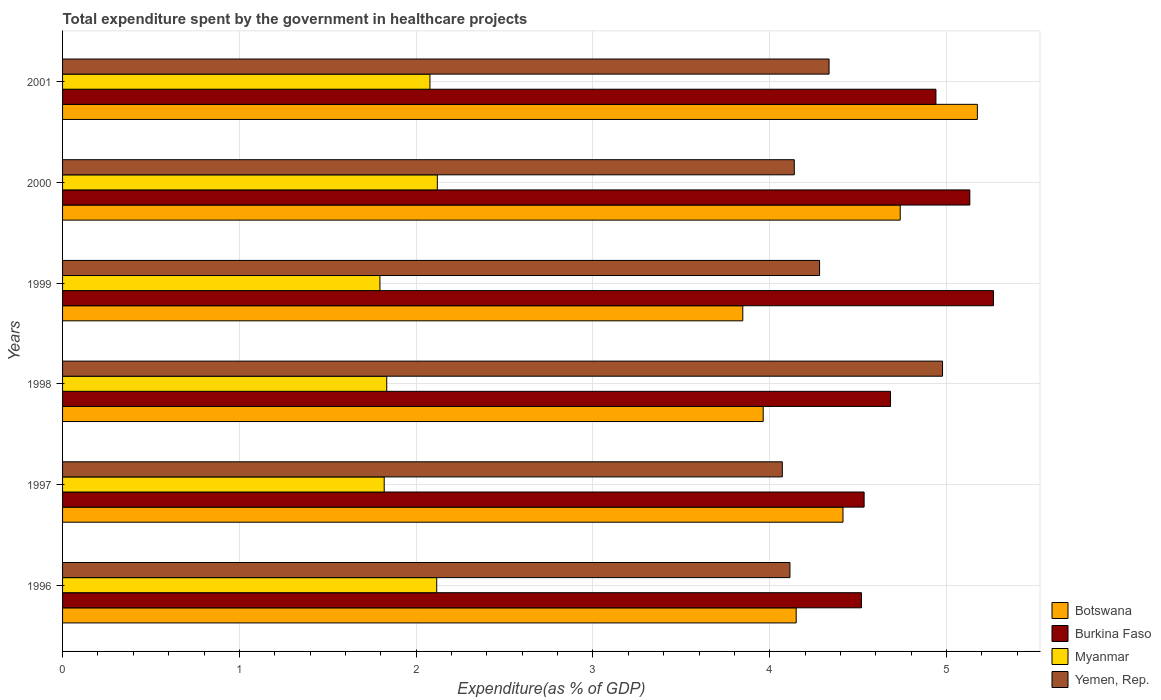How many groups of bars are there?
Offer a terse response. 6. Are the number of bars per tick equal to the number of legend labels?
Make the answer very short. Yes. Are the number of bars on each tick of the Y-axis equal?
Your answer should be very brief. Yes. How many bars are there on the 5th tick from the top?
Ensure brevity in your answer.  4. How many bars are there on the 4th tick from the bottom?
Ensure brevity in your answer.  4. What is the total expenditure spent by the government in healthcare projects in Botswana in 1997?
Provide a short and direct response. 4.41. Across all years, what is the maximum total expenditure spent by the government in healthcare projects in Burkina Faso?
Your response must be concise. 5.26. Across all years, what is the minimum total expenditure spent by the government in healthcare projects in Myanmar?
Your response must be concise. 1.8. In which year was the total expenditure spent by the government in healthcare projects in Botswana maximum?
Offer a terse response. 2001. What is the total total expenditure spent by the government in healthcare projects in Botswana in the graph?
Make the answer very short. 26.29. What is the difference between the total expenditure spent by the government in healthcare projects in Yemen, Rep. in 1999 and that in 2001?
Provide a short and direct response. -0.05. What is the difference between the total expenditure spent by the government in healthcare projects in Botswana in 2000 and the total expenditure spent by the government in healthcare projects in Yemen, Rep. in 2001?
Your answer should be compact. 0.4. What is the average total expenditure spent by the government in healthcare projects in Burkina Faso per year?
Give a very brief answer. 4.85. In the year 1997, what is the difference between the total expenditure spent by the government in healthcare projects in Yemen, Rep. and total expenditure spent by the government in healthcare projects in Burkina Faso?
Offer a very short reply. -0.46. What is the ratio of the total expenditure spent by the government in healthcare projects in Burkina Faso in 1997 to that in 1999?
Make the answer very short. 0.86. Is the difference between the total expenditure spent by the government in healthcare projects in Yemen, Rep. in 1997 and 1998 greater than the difference between the total expenditure spent by the government in healthcare projects in Burkina Faso in 1997 and 1998?
Your answer should be very brief. No. What is the difference between the highest and the second highest total expenditure spent by the government in healthcare projects in Botswana?
Keep it short and to the point. 0.44. What is the difference between the highest and the lowest total expenditure spent by the government in healthcare projects in Yemen, Rep.?
Keep it short and to the point. 0.91. In how many years, is the total expenditure spent by the government in healthcare projects in Myanmar greater than the average total expenditure spent by the government in healthcare projects in Myanmar taken over all years?
Your response must be concise. 3. Is the sum of the total expenditure spent by the government in healthcare projects in Yemen, Rep. in 1997 and 1999 greater than the maximum total expenditure spent by the government in healthcare projects in Burkina Faso across all years?
Ensure brevity in your answer.  Yes. Is it the case that in every year, the sum of the total expenditure spent by the government in healthcare projects in Botswana and total expenditure spent by the government in healthcare projects in Yemen, Rep. is greater than the sum of total expenditure spent by the government in healthcare projects in Burkina Faso and total expenditure spent by the government in healthcare projects in Myanmar?
Offer a very short reply. No. What does the 3rd bar from the top in 1997 represents?
Offer a very short reply. Burkina Faso. What does the 2nd bar from the bottom in 2000 represents?
Provide a succinct answer. Burkina Faso. Is it the case that in every year, the sum of the total expenditure spent by the government in healthcare projects in Yemen, Rep. and total expenditure spent by the government in healthcare projects in Myanmar is greater than the total expenditure spent by the government in healthcare projects in Botswana?
Your answer should be very brief. Yes. How many bars are there?
Your answer should be very brief. 24. Are all the bars in the graph horizontal?
Provide a succinct answer. Yes. What is the difference between two consecutive major ticks on the X-axis?
Provide a short and direct response. 1. Does the graph contain any zero values?
Keep it short and to the point. No. Where does the legend appear in the graph?
Provide a short and direct response. Bottom right. How many legend labels are there?
Provide a succinct answer. 4. What is the title of the graph?
Keep it short and to the point. Total expenditure spent by the government in healthcare projects. Does "Guinea" appear as one of the legend labels in the graph?
Keep it short and to the point. No. What is the label or title of the X-axis?
Your answer should be compact. Expenditure(as % of GDP). What is the Expenditure(as % of GDP) of Botswana in 1996?
Offer a very short reply. 4.15. What is the Expenditure(as % of GDP) of Burkina Faso in 1996?
Keep it short and to the point. 4.52. What is the Expenditure(as % of GDP) in Myanmar in 1996?
Give a very brief answer. 2.12. What is the Expenditure(as % of GDP) of Yemen, Rep. in 1996?
Offer a very short reply. 4.11. What is the Expenditure(as % of GDP) of Botswana in 1997?
Provide a succinct answer. 4.41. What is the Expenditure(as % of GDP) in Burkina Faso in 1997?
Your answer should be compact. 4.53. What is the Expenditure(as % of GDP) of Myanmar in 1997?
Make the answer very short. 1.82. What is the Expenditure(as % of GDP) of Yemen, Rep. in 1997?
Your response must be concise. 4.07. What is the Expenditure(as % of GDP) of Botswana in 1998?
Offer a terse response. 3.96. What is the Expenditure(as % of GDP) of Burkina Faso in 1998?
Ensure brevity in your answer.  4.68. What is the Expenditure(as % of GDP) in Myanmar in 1998?
Provide a succinct answer. 1.83. What is the Expenditure(as % of GDP) in Yemen, Rep. in 1998?
Give a very brief answer. 4.98. What is the Expenditure(as % of GDP) of Botswana in 1999?
Keep it short and to the point. 3.85. What is the Expenditure(as % of GDP) of Burkina Faso in 1999?
Provide a succinct answer. 5.26. What is the Expenditure(as % of GDP) in Myanmar in 1999?
Give a very brief answer. 1.8. What is the Expenditure(as % of GDP) in Yemen, Rep. in 1999?
Your response must be concise. 4.28. What is the Expenditure(as % of GDP) of Botswana in 2000?
Give a very brief answer. 4.74. What is the Expenditure(as % of GDP) of Burkina Faso in 2000?
Give a very brief answer. 5.13. What is the Expenditure(as % of GDP) of Myanmar in 2000?
Keep it short and to the point. 2.12. What is the Expenditure(as % of GDP) in Yemen, Rep. in 2000?
Provide a short and direct response. 4.14. What is the Expenditure(as % of GDP) in Botswana in 2001?
Keep it short and to the point. 5.17. What is the Expenditure(as % of GDP) of Burkina Faso in 2001?
Your answer should be very brief. 4.94. What is the Expenditure(as % of GDP) of Myanmar in 2001?
Your answer should be very brief. 2.08. What is the Expenditure(as % of GDP) in Yemen, Rep. in 2001?
Your answer should be very brief. 4.34. Across all years, what is the maximum Expenditure(as % of GDP) in Botswana?
Your answer should be very brief. 5.17. Across all years, what is the maximum Expenditure(as % of GDP) in Burkina Faso?
Offer a terse response. 5.26. Across all years, what is the maximum Expenditure(as % of GDP) of Myanmar?
Your answer should be compact. 2.12. Across all years, what is the maximum Expenditure(as % of GDP) of Yemen, Rep.?
Your response must be concise. 4.98. Across all years, what is the minimum Expenditure(as % of GDP) of Botswana?
Make the answer very short. 3.85. Across all years, what is the minimum Expenditure(as % of GDP) of Burkina Faso?
Offer a very short reply. 4.52. Across all years, what is the minimum Expenditure(as % of GDP) of Myanmar?
Ensure brevity in your answer.  1.8. Across all years, what is the minimum Expenditure(as % of GDP) in Yemen, Rep.?
Keep it short and to the point. 4.07. What is the total Expenditure(as % of GDP) in Botswana in the graph?
Ensure brevity in your answer.  26.29. What is the total Expenditure(as % of GDP) in Burkina Faso in the graph?
Offer a very short reply. 29.07. What is the total Expenditure(as % of GDP) in Myanmar in the graph?
Your answer should be very brief. 11.76. What is the total Expenditure(as % of GDP) of Yemen, Rep. in the graph?
Your response must be concise. 25.92. What is the difference between the Expenditure(as % of GDP) of Botswana in 1996 and that in 1997?
Offer a terse response. -0.26. What is the difference between the Expenditure(as % of GDP) in Burkina Faso in 1996 and that in 1997?
Keep it short and to the point. -0.01. What is the difference between the Expenditure(as % of GDP) in Myanmar in 1996 and that in 1997?
Provide a succinct answer. 0.3. What is the difference between the Expenditure(as % of GDP) in Yemen, Rep. in 1996 and that in 1997?
Ensure brevity in your answer.  0.04. What is the difference between the Expenditure(as % of GDP) of Botswana in 1996 and that in 1998?
Keep it short and to the point. 0.19. What is the difference between the Expenditure(as % of GDP) in Burkina Faso in 1996 and that in 1998?
Offer a terse response. -0.16. What is the difference between the Expenditure(as % of GDP) in Myanmar in 1996 and that in 1998?
Keep it short and to the point. 0.28. What is the difference between the Expenditure(as % of GDP) of Yemen, Rep. in 1996 and that in 1998?
Your answer should be compact. -0.86. What is the difference between the Expenditure(as % of GDP) of Botswana in 1996 and that in 1999?
Offer a very short reply. 0.3. What is the difference between the Expenditure(as % of GDP) in Burkina Faso in 1996 and that in 1999?
Provide a short and direct response. -0.75. What is the difference between the Expenditure(as % of GDP) in Myanmar in 1996 and that in 1999?
Provide a short and direct response. 0.32. What is the difference between the Expenditure(as % of GDP) in Yemen, Rep. in 1996 and that in 1999?
Give a very brief answer. -0.17. What is the difference between the Expenditure(as % of GDP) of Botswana in 1996 and that in 2000?
Your answer should be compact. -0.59. What is the difference between the Expenditure(as % of GDP) of Burkina Faso in 1996 and that in 2000?
Keep it short and to the point. -0.61. What is the difference between the Expenditure(as % of GDP) in Myanmar in 1996 and that in 2000?
Offer a very short reply. -0. What is the difference between the Expenditure(as % of GDP) in Yemen, Rep. in 1996 and that in 2000?
Keep it short and to the point. -0.02. What is the difference between the Expenditure(as % of GDP) of Botswana in 1996 and that in 2001?
Provide a succinct answer. -1.02. What is the difference between the Expenditure(as % of GDP) of Burkina Faso in 1996 and that in 2001?
Your response must be concise. -0.42. What is the difference between the Expenditure(as % of GDP) in Myanmar in 1996 and that in 2001?
Keep it short and to the point. 0.04. What is the difference between the Expenditure(as % of GDP) of Yemen, Rep. in 1996 and that in 2001?
Offer a very short reply. -0.22. What is the difference between the Expenditure(as % of GDP) of Botswana in 1997 and that in 1998?
Your response must be concise. 0.45. What is the difference between the Expenditure(as % of GDP) of Burkina Faso in 1997 and that in 1998?
Offer a terse response. -0.15. What is the difference between the Expenditure(as % of GDP) of Myanmar in 1997 and that in 1998?
Provide a short and direct response. -0.01. What is the difference between the Expenditure(as % of GDP) of Yemen, Rep. in 1997 and that in 1998?
Your response must be concise. -0.91. What is the difference between the Expenditure(as % of GDP) of Botswana in 1997 and that in 1999?
Your answer should be very brief. 0.57. What is the difference between the Expenditure(as % of GDP) in Burkina Faso in 1997 and that in 1999?
Ensure brevity in your answer.  -0.73. What is the difference between the Expenditure(as % of GDP) in Myanmar in 1997 and that in 1999?
Keep it short and to the point. 0.02. What is the difference between the Expenditure(as % of GDP) of Yemen, Rep. in 1997 and that in 1999?
Make the answer very short. -0.21. What is the difference between the Expenditure(as % of GDP) of Botswana in 1997 and that in 2000?
Your answer should be very brief. -0.32. What is the difference between the Expenditure(as % of GDP) in Burkina Faso in 1997 and that in 2000?
Make the answer very short. -0.6. What is the difference between the Expenditure(as % of GDP) in Myanmar in 1997 and that in 2000?
Your answer should be compact. -0.3. What is the difference between the Expenditure(as % of GDP) of Yemen, Rep. in 1997 and that in 2000?
Keep it short and to the point. -0.07. What is the difference between the Expenditure(as % of GDP) of Botswana in 1997 and that in 2001?
Your answer should be very brief. -0.76. What is the difference between the Expenditure(as % of GDP) of Burkina Faso in 1997 and that in 2001?
Provide a succinct answer. -0.41. What is the difference between the Expenditure(as % of GDP) in Myanmar in 1997 and that in 2001?
Offer a terse response. -0.26. What is the difference between the Expenditure(as % of GDP) in Yemen, Rep. in 1997 and that in 2001?
Keep it short and to the point. -0.26. What is the difference between the Expenditure(as % of GDP) of Botswana in 1998 and that in 1999?
Offer a terse response. 0.12. What is the difference between the Expenditure(as % of GDP) in Burkina Faso in 1998 and that in 1999?
Ensure brevity in your answer.  -0.58. What is the difference between the Expenditure(as % of GDP) of Myanmar in 1998 and that in 1999?
Provide a short and direct response. 0.04. What is the difference between the Expenditure(as % of GDP) in Yemen, Rep. in 1998 and that in 1999?
Make the answer very short. 0.7. What is the difference between the Expenditure(as % of GDP) in Botswana in 1998 and that in 2000?
Give a very brief answer. -0.77. What is the difference between the Expenditure(as % of GDP) of Burkina Faso in 1998 and that in 2000?
Make the answer very short. -0.45. What is the difference between the Expenditure(as % of GDP) of Myanmar in 1998 and that in 2000?
Your answer should be compact. -0.29. What is the difference between the Expenditure(as % of GDP) in Yemen, Rep. in 1998 and that in 2000?
Offer a terse response. 0.84. What is the difference between the Expenditure(as % of GDP) in Botswana in 1998 and that in 2001?
Provide a succinct answer. -1.21. What is the difference between the Expenditure(as % of GDP) of Burkina Faso in 1998 and that in 2001?
Your answer should be compact. -0.26. What is the difference between the Expenditure(as % of GDP) of Myanmar in 1998 and that in 2001?
Offer a terse response. -0.24. What is the difference between the Expenditure(as % of GDP) of Yemen, Rep. in 1998 and that in 2001?
Offer a terse response. 0.64. What is the difference between the Expenditure(as % of GDP) of Botswana in 1999 and that in 2000?
Give a very brief answer. -0.89. What is the difference between the Expenditure(as % of GDP) of Burkina Faso in 1999 and that in 2000?
Provide a succinct answer. 0.13. What is the difference between the Expenditure(as % of GDP) of Myanmar in 1999 and that in 2000?
Keep it short and to the point. -0.32. What is the difference between the Expenditure(as % of GDP) of Yemen, Rep. in 1999 and that in 2000?
Provide a succinct answer. 0.14. What is the difference between the Expenditure(as % of GDP) in Botswana in 1999 and that in 2001?
Keep it short and to the point. -1.33. What is the difference between the Expenditure(as % of GDP) of Burkina Faso in 1999 and that in 2001?
Make the answer very short. 0.33. What is the difference between the Expenditure(as % of GDP) in Myanmar in 1999 and that in 2001?
Give a very brief answer. -0.28. What is the difference between the Expenditure(as % of GDP) in Yemen, Rep. in 1999 and that in 2001?
Your response must be concise. -0.05. What is the difference between the Expenditure(as % of GDP) in Botswana in 2000 and that in 2001?
Keep it short and to the point. -0.44. What is the difference between the Expenditure(as % of GDP) in Burkina Faso in 2000 and that in 2001?
Your answer should be very brief. 0.19. What is the difference between the Expenditure(as % of GDP) of Myanmar in 2000 and that in 2001?
Give a very brief answer. 0.04. What is the difference between the Expenditure(as % of GDP) of Yemen, Rep. in 2000 and that in 2001?
Make the answer very short. -0.2. What is the difference between the Expenditure(as % of GDP) in Botswana in 1996 and the Expenditure(as % of GDP) in Burkina Faso in 1997?
Provide a succinct answer. -0.38. What is the difference between the Expenditure(as % of GDP) of Botswana in 1996 and the Expenditure(as % of GDP) of Myanmar in 1997?
Keep it short and to the point. 2.33. What is the difference between the Expenditure(as % of GDP) in Botswana in 1996 and the Expenditure(as % of GDP) in Yemen, Rep. in 1997?
Keep it short and to the point. 0.08. What is the difference between the Expenditure(as % of GDP) of Burkina Faso in 1996 and the Expenditure(as % of GDP) of Myanmar in 1997?
Give a very brief answer. 2.7. What is the difference between the Expenditure(as % of GDP) in Burkina Faso in 1996 and the Expenditure(as % of GDP) in Yemen, Rep. in 1997?
Offer a very short reply. 0.45. What is the difference between the Expenditure(as % of GDP) in Myanmar in 1996 and the Expenditure(as % of GDP) in Yemen, Rep. in 1997?
Your answer should be compact. -1.95. What is the difference between the Expenditure(as % of GDP) in Botswana in 1996 and the Expenditure(as % of GDP) in Burkina Faso in 1998?
Make the answer very short. -0.53. What is the difference between the Expenditure(as % of GDP) in Botswana in 1996 and the Expenditure(as % of GDP) in Myanmar in 1998?
Provide a short and direct response. 2.32. What is the difference between the Expenditure(as % of GDP) in Botswana in 1996 and the Expenditure(as % of GDP) in Yemen, Rep. in 1998?
Give a very brief answer. -0.83. What is the difference between the Expenditure(as % of GDP) in Burkina Faso in 1996 and the Expenditure(as % of GDP) in Myanmar in 1998?
Your answer should be compact. 2.69. What is the difference between the Expenditure(as % of GDP) in Burkina Faso in 1996 and the Expenditure(as % of GDP) in Yemen, Rep. in 1998?
Ensure brevity in your answer.  -0.46. What is the difference between the Expenditure(as % of GDP) of Myanmar in 1996 and the Expenditure(as % of GDP) of Yemen, Rep. in 1998?
Keep it short and to the point. -2.86. What is the difference between the Expenditure(as % of GDP) in Botswana in 1996 and the Expenditure(as % of GDP) in Burkina Faso in 1999?
Keep it short and to the point. -1.12. What is the difference between the Expenditure(as % of GDP) in Botswana in 1996 and the Expenditure(as % of GDP) in Myanmar in 1999?
Provide a succinct answer. 2.35. What is the difference between the Expenditure(as % of GDP) in Botswana in 1996 and the Expenditure(as % of GDP) in Yemen, Rep. in 1999?
Offer a very short reply. -0.13. What is the difference between the Expenditure(as % of GDP) in Burkina Faso in 1996 and the Expenditure(as % of GDP) in Myanmar in 1999?
Provide a succinct answer. 2.72. What is the difference between the Expenditure(as % of GDP) in Burkina Faso in 1996 and the Expenditure(as % of GDP) in Yemen, Rep. in 1999?
Your answer should be very brief. 0.24. What is the difference between the Expenditure(as % of GDP) in Myanmar in 1996 and the Expenditure(as % of GDP) in Yemen, Rep. in 1999?
Keep it short and to the point. -2.17. What is the difference between the Expenditure(as % of GDP) in Botswana in 1996 and the Expenditure(as % of GDP) in Burkina Faso in 2000?
Ensure brevity in your answer.  -0.98. What is the difference between the Expenditure(as % of GDP) in Botswana in 1996 and the Expenditure(as % of GDP) in Myanmar in 2000?
Give a very brief answer. 2.03. What is the difference between the Expenditure(as % of GDP) in Botswana in 1996 and the Expenditure(as % of GDP) in Yemen, Rep. in 2000?
Offer a very short reply. 0.01. What is the difference between the Expenditure(as % of GDP) of Burkina Faso in 1996 and the Expenditure(as % of GDP) of Myanmar in 2000?
Your response must be concise. 2.4. What is the difference between the Expenditure(as % of GDP) of Burkina Faso in 1996 and the Expenditure(as % of GDP) of Yemen, Rep. in 2000?
Your answer should be very brief. 0.38. What is the difference between the Expenditure(as % of GDP) in Myanmar in 1996 and the Expenditure(as % of GDP) in Yemen, Rep. in 2000?
Offer a terse response. -2.02. What is the difference between the Expenditure(as % of GDP) in Botswana in 1996 and the Expenditure(as % of GDP) in Burkina Faso in 2001?
Your answer should be very brief. -0.79. What is the difference between the Expenditure(as % of GDP) of Botswana in 1996 and the Expenditure(as % of GDP) of Myanmar in 2001?
Give a very brief answer. 2.07. What is the difference between the Expenditure(as % of GDP) in Botswana in 1996 and the Expenditure(as % of GDP) in Yemen, Rep. in 2001?
Provide a short and direct response. -0.19. What is the difference between the Expenditure(as % of GDP) in Burkina Faso in 1996 and the Expenditure(as % of GDP) in Myanmar in 2001?
Provide a succinct answer. 2.44. What is the difference between the Expenditure(as % of GDP) in Burkina Faso in 1996 and the Expenditure(as % of GDP) in Yemen, Rep. in 2001?
Ensure brevity in your answer.  0.18. What is the difference between the Expenditure(as % of GDP) of Myanmar in 1996 and the Expenditure(as % of GDP) of Yemen, Rep. in 2001?
Provide a short and direct response. -2.22. What is the difference between the Expenditure(as % of GDP) in Botswana in 1997 and the Expenditure(as % of GDP) in Burkina Faso in 1998?
Offer a terse response. -0.27. What is the difference between the Expenditure(as % of GDP) in Botswana in 1997 and the Expenditure(as % of GDP) in Myanmar in 1998?
Offer a terse response. 2.58. What is the difference between the Expenditure(as % of GDP) in Botswana in 1997 and the Expenditure(as % of GDP) in Yemen, Rep. in 1998?
Keep it short and to the point. -0.56. What is the difference between the Expenditure(as % of GDP) of Burkina Faso in 1997 and the Expenditure(as % of GDP) of Myanmar in 1998?
Provide a succinct answer. 2.7. What is the difference between the Expenditure(as % of GDP) of Burkina Faso in 1997 and the Expenditure(as % of GDP) of Yemen, Rep. in 1998?
Provide a short and direct response. -0.44. What is the difference between the Expenditure(as % of GDP) in Myanmar in 1997 and the Expenditure(as % of GDP) in Yemen, Rep. in 1998?
Your answer should be very brief. -3.16. What is the difference between the Expenditure(as % of GDP) in Botswana in 1997 and the Expenditure(as % of GDP) in Burkina Faso in 1999?
Ensure brevity in your answer.  -0.85. What is the difference between the Expenditure(as % of GDP) in Botswana in 1997 and the Expenditure(as % of GDP) in Myanmar in 1999?
Make the answer very short. 2.62. What is the difference between the Expenditure(as % of GDP) in Botswana in 1997 and the Expenditure(as % of GDP) in Yemen, Rep. in 1999?
Offer a terse response. 0.13. What is the difference between the Expenditure(as % of GDP) in Burkina Faso in 1997 and the Expenditure(as % of GDP) in Myanmar in 1999?
Offer a very short reply. 2.74. What is the difference between the Expenditure(as % of GDP) of Burkina Faso in 1997 and the Expenditure(as % of GDP) of Yemen, Rep. in 1999?
Provide a succinct answer. 0.25. What is the difference between the Expenditure(as % of GDP) in Myanmar in 1997 and the Expenditure(as % of GDP) in Yemen, Rep. in 1999?
Offer a terse response. -2.46. What is the difference between the Expenditure(as % of GDP) in Botswana in 1997 and the Expenditure(as % of GDP) in Burkina Faso in 2000?
Make the answer very short. -0.72. What is the difference between the Expenditure(as % of GDP) of Botswana in 1997 and the Expenditure(as % of GDP) of Myanmar in 2000?
Your response must be concise. 2.29. What is the difference between the Expenditure(as % of GDP) in Botswana in 1997 and the Expenditure(as % of GDP) in Yemen, Rep. in 2000?
Keep it short and to the point. 0.28. What is the difference between the Expenditure(as % of GDP) in Burkina Faso in 1997 and the Expenditure(as % of GDP) in Myanmar in 2000?
Provide a succinct answer. 2.41. What is the difference between the Expenditure(as % of GDP) of Burkina Faso in 1997 and the Expenditure(as % of GDP) of Yemen, Rep. in 2000?
Your answer should be compact. 0.4. What is the difference between the Expenditure(as % of GDP) in Myanmar in 1997 and the Expenditure(as % of GDP) in Yemen, Rep. in 2000?
Provide a succinct answer. -2.32. What is the difference between the Expenditure(as % of GDP) in Botswana in 1997 and the Expenditure(as % of GDP) in Burkina Faso in 2001?
Keep it short and to the point. -0.53. What is the difference between the Expenditure(as % of GDP) of Botswana in 1997 and the Expenditure(as % of GDP) of Myanmar in 2001?
Give a very brief answer. 2.34. What is the difference between the Expenditure(as % of GDP) in Botswana in 1997 and the Expenditure(as % of GDP) in Yemen, Rep. in 2001?
Give a very brief answer. 0.08. What is the difference between the Expenditure(as % of GDP) in Burkina Faso in 1997 and the Expenditure(as % of GDP) in Myanmar in 2001?
Offer a terse response. 2.46. What is the difference between the Expenditure(as % of GDP) in Burkina Faso in 1997 and the Expenditure(as % of GDP) in Yemen, Rep. in 2001?
Your answer should be compact. 0.2. What is the difference between the Expenditure(as % of GDP) in Myanmar in 1997 and the Expenditure(as % of GDP) in Yemen, Rep. in 2001?
Your answer should be compact. -2.52. What is the difference between the Expenditure(as % of GDP) in Botswana in 1998 and the Expenditure(as % of GDP) in Burkina Faso in 1999?
Your answer should be very brief. -1.3. What is the difference between the Expenditure(as % of GDP) in Botswana in 1998 and the Expenditure(as % of GDP) in Myanmar in 1999?
Provide a short and direct response. 2.17. What is the difference between the Expenditure(as % of GDP) of Botswana in 1998 and the Expenditure(as % of GDP) of Yemen, Rep. in 1999?
Offer a very short reply. -0.32. What is the difference between the Expenditure(as % of GDP) in Burkina Faso in 1998 and the Expenditure(as % of GDP) in Myanmar in 1999?
Offer a terse response. 2.89. What is the difference between the Expenditure(as % of GDP) in Burkina Faso in 1998 and the Expenditure(as % of GDP) in Yemen, Rep. in 1999?
Offer a very short reply. 0.4. What is the difference between the Expenditure(as % of GDP) of Myanmar in 1998 and the Expenditure(as % of GDP) of Yemen, Rep. in 1999?
Give a very brief answer. -2.45. What is the difference between the Expenditure(as % of GDP) in Botswana in 1998 and the Expenditure(as % of GDP) in Burkina Faso in 2000?
Provide a succinct answer. -1.17. What is the difference between the Expenditure(as % of GDP) of Botswana in 1998 and the Expenditure(as % of GDP) of Myanmar in 2000?
Make the answer very short. 1.84. What is the difference between the Expenditure(as % of GDP) of Botswana in 1998 and the Expenditure(as % of GDP) of Yemen, Rep. in 2000?
Make the answer very short. -0.18. What is the difference between the Expenditure(as % of GDP) in Burkina Faso in 1998 and the Expenditure(as % of GDP) in Myanmar in 2000?
Your response must be concise. 2.56. What is the difference between the Expenditure(as % of GDP) of Burkina Faso in 1998 and the Expenditure(as % of GDP) of Yemen, Rep. in 2000?
Provide a succinct answer. 0.54. What is the difference between the Expenditure(as % of GDP) of Myanmar in 1998 and the Expenditure(as % of GDP) of Yemen, Rep. in 2000?
Provide a short and direct response. -2.31. What is the difference between the Expenditure(as % of GDP) of Botswana in 1998 and the Expenditure(as % of GDP) of Burkina Faso in 2001?
Your response must be concise. -0.98. What is the difference between the Expenditure(as % of GDP) of Botswana in 1998 and the Expenditure(as % of GDP) of Myanmar in 2001?
Provide a short and direct response. 1.89. What is the difference between the Expenditure(as % of GDP) of Botswana in 1998 and the Expenditure(as % of GDP) of Yemen, Rep. in 2001?
Provide a short and direct response. -0.37. What is the difference between the Expenditure(as % of GDP) of Burkina Faso in 1998 and the Expenditure(as % of GDP) of Myanmar in 2001?
Keep it short and to the point. 2.6. What is the difference between the Expenditure(as % of GDP) of Burkina Faso in 1998 and the Expenditure(as % of GDP) of Yemen, Rep. in 2001?
Provide a short and direct response. 0.35. What is the difference between the Expenditure(as % of GDP) of Myanmar in 1998 and the Expenditure(as % of GDP) of Yemen, Rep. in 2001?
Provide a short and direct response. -2.5. What is the difference between the Expenditure(as % of GDP) of Botswana in 1999 and the Expenditure(as % of GDP) of Burkina Faso in 2000?
Make the answer very short. -1.28. What is the difference between the Expenditure(as % of GDP) of Botswana in 1999 and the Expenditure(as % of GDP) of Myanmar in 2000?
Give a very brief answer. 1.73. What is the difference between the Expenditure(as % of GDP) in Botswana in 1999 and the Expenditure(as % of GDP) in Yemen, Rep. in 2000?
Make the answer very short. -0.29. What is the difference between the Expenditure(as % of GDP) of Burkina Faso in 1999 and the Expenditure(as % of GDP) of Myanmar in 2000?
Provide a short and direct response. 3.15. What is the difference between the Expenditure(as % of GDP) in Burkina Faso in 1999 and the Expenditure(as % of GDP) in Yemen, Rep. in 2000?
Give a very brief answer. 1.13. What is the difference between the Expenditure(as % of GDP) in Myanmar in 1999 and the Expenditure(as % of GDP) in Yemen, Rep. in 2000?
Offer a very short reply. -2.34. What is the difference between the Expenditure(as % of GDP) of Botswana in 1999 and the Expenditure(as % of GDP) of Burkina Faso in 2001?
Your answer should be very brief. -1.09. What is the difference between the Expenditure(as % of GDP) in Botswana in 1999 and the Expenditure(as % of GDP) in Myanmar in 2001?
Provide a succinct answer. 1.77. What is the difference between the Expenditure(as % of GDP) in Botswana in 1999 and the Expenditure(as % of GDP) in Yemen, Rep. in 2001?
Make the answer very short. -0.49. What is the difference between the Expenditure(as % of GDP) of Burkina Faso in 1999 and the Expenditure(as % of GDP) of Myanmar in 2001?
Give a very brief answer. 3.19. What is the difference between the Expenditure(as % of GDP) in Burkina Faso in 1999 and the Expenditure(as % of GDP) in Yemen, Rep. in 2001?
Your response must be concise. 0.93. What is the difference between the Expenditure(as % of GDP) of Myanmar in 1999 and the Expenditure(as % of GDP) of Yemen, Rep. in 2001?
Your answer should be compact. -2.54. What is the difference between the Expenditure(as % of GDP) in Botswana in 2000 and the Expenditure(as % of GDP) in Burkina Faso in 2001?
Offer a very short reply. -0.2. What is the difference between the Expenditure(as % of GDP) of Botswana in 2000 and the Expenditure(as % of GDP) of Myanmar in 2001?
Your answer should be compact. 2.66. What is the difference between the Expenditure(as % of GDP) in Botswana in 2000 and the Expenditure(as % of GDP) in Yemen, Rep. in 2001?
Your answer should be very brief. 0.4. What is the difference between the Expenditure(as % of GDP) of Burkina Faso in 2000 and the Expenditure(as % of GDP) of Myanmar in 2001?
Your response must be concise. 3.05. What is the difference between the Expenditure(as % of GDP) of Burkina Faso in 2000 and the Expenditure(as % of GDP) of Yemen, Rep. in 2001?
Your answer should be very brief. 0.8. What is the difference between the Expenditure(as % of GDP) of Myanmar in 2000 and the Expenditure(as % of GDP) of Yemen, Rep. in 2001?
Provide a succinct answer. -2.22. What is the average Expenditure(as % of GDP) of Botswana per year?
Ensure brevity in your answer.  4.38. What is the average Expenditure(as % of GDP) in Burkina Faso per year?
Offer a terse response. 4.85. What is the average Expenditure(as % of GDP) of Myanmar per year?
Provide a short and direct response. 1.96. What is the average Expenditure(as % of GDP) in Yemen, Rep. per year?
Offer a very short reply. 4.32. In the year 1996, what is the difference between the Expenditure(as % of GDP) in Botswana and Expenditure(as % of GDP) in Burkina Faso?
Your response must be concise. -0.37. In the year 1996, what is the difference between the Expenditure(as % of GDP) in Botswana and Expenditure(as % of GDP) in Myanmar?
Provide a succinct answer. 2.03. In the year 1996, what is the difference between the Expenditure(as % of GDP) in Botswana and Expenditure(as % of GDP) in Yemen, Rep.?
Your response must be concise. 0.04. In the year 1996, what is the difference between the Expenditure(as % of GDP) in Burkina Faso and Expenditure(as % of GDP) in Myanmar?
Offer a very short reply. 2.4. In the year 1996, what is the difference between the Expenditure(as % of GDP) in Burkina Faso and Expenditure(as % of GDP) in Yemen, Rep.?
Provide a succinct answer. 0.4. In the year 1996, what is the difference between the Expenditure(as % of GDP) in Myanmar and Expenditure(as % of GDP) in Yemen, Rep.?
Your response must be concise. -2. In the year 1997, what is the difference between the Expenditure(as % of GDP) in Botswana and Expenditure(as % of GDP) in Burkina Faso?
Offer a very short reply. -0.12. In the year 1997, what is the difference between the Expenditure(as % of GDP) of Botswana and Expenditure(as % of GDP) of Myanmar?
Your answer should be compact. 2.6. In the year 1997, what is the difference between the Expenditure(as % of GDP) of Botswana and Expenditure(as % of GDP) of Yemen, Rep.?
Offer a terse response. 0.34. In the year 1997, what is the difference between the Expenditure(as % of GDP) of Burkina Faso and Expenditure(as % of GDP) of Myanmar?
Ensure brevity in your answer.  2.71. In the year 1997, what is the difference between the Expenditure(as % of GDP) in Burkina Faso and Expenditure(as % of GDP) in Yemen, Rep.?
Give a very brief answer. 0.46. In the year 1997, what is the difference between the Expenditure(as % of GDP) in Myanmar and Expenditure(as % of GDP) in Yemen, Rep.?
Provide a succinct answer. -2.25. In the year 1998, what is the difference between the Expenditure(as % of GDP) in Botswana and Expenditure(as % of GDP) in Burkina Faso?
Make the answer very short. -0.72. In the year 1998, what is the difference between the Expenditure(as % of GDP) in Botswana and Expenditure(as % of GDP) in Myanmar?
Offer a terse response. 2.13. In the year 1998, what is the difference between the Expenditure(as % of GDP) in Botswana and Expenditure(as % of GDP) in Yemen, Rep.?
Make the answer very short. -1.01. In the year 1998, what is the difference between the Expenditure(as % of GDP) of Burkina Faso and Expenditure(as % of GDP) of Myanmar?
Provide a succinct answer. 2.85. In the year 1998, what is the difference between the Expenditure(as % of GDP) of Burkina Faso and Expenditure(as % of GDP) of Yemen, Rep.?
Your response must be concise. -0.29. In the year 1998, what is the difference between the Expenditure(as % of GDP) of Myanmar and Expenditure(as % of GDP) of Yemen, Rep.?
Provide a succinct answer. -3.14. In the year 1999, what is the difference between the Expenditure(as % of GDP) in Botswana and Expenditure(as % of GDP) in Burkina Faso?
Your response must be concise. -1.42. In the year 1999, what is the difference between the Expenditure(as % of GDP) of Botswana and Expenditure(as % of GDP) of Myanmar?
Your answer should be compact. 2.05. In the year 1999, what is the difference between the Expenditure(as % of GDP) of Botswana and Expenditure(as % of GDP) of Yemen, Rep.?
Offer a very short reply. -0.43. In the year 1999, what is the difference between the Expenditure(as % of GDP) in Burkina Faso and Expenditure(as % of GDP) in Myanmar?
Offer a very short reply. 3.47. In the year 1999, what is the difference between the Expenditure(as % of GDP) in Burkina Faso and Expenditure(as % of GDP) in Yemen, Rep.?
Provide a succinct answer. 0.98. In the year 1999, what is the difference between the Expenditure(as % of GDP) in Myanmar and Expenditure(as % of GDP) in Yemen, Rep.?
Offer a terse response. -2.49. In the year 2000, what is the difference between the Expenditure(as % of GDP) of Botswana and Expenditure(as % of GDP) of Burkina Faso?
Offer a very short reply. -0.39. In the year 2000, what is the difference between the Expenditure(as % of GDP) in Botswana and Expenditure(as % of GDP) in Myanmar?
Your response must be concise. 2.62. In the year 2000, what is the difference between the Expenditure(as % of GDP) in Botswana and Expenditure(as % of GDP) in Yemen, Rep.?
Provide a succinct answer. 0.6. In the year 2000, what is the difference between the Expenditure(as % of GDP) of Burkina Faso and Expenditure(as % of GDP) of Myanmar?
Your answer should be very brief. 3.01. In the year 2000, what is the difference between the Expenditure(as % of GDP) of Myanmar and Expenditure(as % of GDP) of Yemen, Rep.?
Your response must be concise. -2.02. In the year 2001, what is the difference between the Expenditure(as % of GDP) in Botswana and Expenditure(as % of GDP) in Burkina Faso?
Ensure brevity in your answer.  0.23. In the year 2001, what is the difference between the Expenditure(as % of GDP) of Botswana and Expenditure(as % of GDP) of Myanmar?
Your response must be concise. 3.1. In the year 2001, what is the difference between the Expenditure(as % of GDP) in Botswana and Expenditure(as % of GDP) in Yemen, Rep.?
Make the answer very short. 0.84. In the year 2001, what is the difference between the Expenditure(as % of GDP) in Burkina Faso and Expenditure(as % of GDP) in Myanmar?
Your answer should be compact. 2.86. In the year 2001, what is the difference between the Expenditure(as % of GDP) in Burkina Faso and Expenditure(as % of GDP) in Yemen, Rep.?
Give a very brief answer. 0.6. In the year 2001, what is the difference between the Expenditure(as % of GDP) in Myanmar and Expenditure(as % of GDP) in Yemen, Rep.?
Provide a short and direct response. -2.26. What is the ratio of the Expenditure(as % of GDP) of Botswana in 1996 to that in 1997?
Your answer should be compact. 0.94. What is the ratio of the Expenditure(as % of GDP) in Burkina Faso in 1996 to that in 1997?
Make the answer very short. 1. What is the ratio of the Expenditure(as % of GDP) in Myanmar in 1996 to that in 1997?
Your answer should be compact. 1.16. What is the ratio of the Expenditure(as % of GDP) of Yemen, Rep. in 1996 to that in 1997?
Make the answer very short. 1.01. What is the ratio of the Expenditure(as % of GDP) in Botswana in 1996 to that in 1998?
Your response must be concise. 1.05. What is the ratio of the Expenditure(as % of GDP) of Burkina Faso in 1996 to that in 1998?
Your answer should be compact. 0.96. What is the ratio of the Expenditure(as % of GDP) of Myanmar in 1996 to that in 1998?
Give a very brief answer. 1.15. What is the ratio of the Expenditure(as % of GDP) in Yemen, Rep. in 1996 to that in 1998?
Offer a very short reply. 0.83. What is the ratio of the Expenditure(as % of GDP) of Botswana in 1996 to that in 1999?
Offer a terse response. 1.08. What is the ratio of the Expenditure(as % of GDP) in Burkina Faso in 1996 to that in 1999?
Offer a terse response. 0.86. What is the ratio of the Expenditure(as % of GDP) of Myanmar in 1996 to that in 1999?
Ensure brevity in your answer.  1.18. What is the ratio of the Expenditure(as % of GDP) in Yemen, Rep. in 1996 to that in 1999?
Offer a terse response. 0.96. What is the ratio of the Expenditure(as % of GDP) in Botswana in 1996 to that in 2000?
Give a very brief answer. 0.88. What is the ratio of the Expenditure(as % of GDP) in Burkina Faso in 1996 to that in 2000?
Provide a short and direct response. 0.88. What is the ratio of the Expenditure(as % of GDP) of Myanmar in 1996 to that in 2000?
Provide a short and direct response. 1. What is the ratio of the Expenditure(as % of GDP) in Yemen, Rep. in 1996 to that in 2000?
Ensure brevity in your answer.  0.99. What is the ratio of the Expenditure(as % of GDP) in Botswana in 1996 to that in 2001?
Provide a short and direct response. 0.8. What is the ratio of the Expenditure(as % of GDP) in Burkina Faso in 1996 to that in 2001?
Ensure brevity in your answer.  0.91. What is the ratio of the Expenditure(as % of GDP) of Myanmar in 1996 to that in 2001?
Provide a short and direct response. 1.02. What is the ratio of the Expenditure(as % of GDP) of Yemen, Rep. in 1996 to that in 2001?
Offer a terse response. 0.95. What is the ratio of the Expenditure(as % of GDP) in Botswana in 1997 to that in 1998?
Offer a very short reply. 1.11. What is the ratio of the Expenditure(as % of GDP) of Burkina Faso in 1997 to that in 1998?
Ensure brevity in your answer.  0.97. What is the ratio of the Expenditure(as % of GDP) in Myanmar in 1997 to that in 1998?
Give a very brief answer. 0.99. What is the ratio of the Expenditure(as % of GDP) in Yemen, Rep. in 1997 to that in 1998?
Offer a very short reply. 0.82. What is the ratio of the Expenditure(as % of GDP) in Botswana in 1997 to that in 1999?
Offer a very short reply. 1.15. What is the ratio of the Expenditure(as % of GDP) of Burkina Faso in 1997 to that in 1999?
Ensure brevity in your answer.  0.86. What is the ratio of the Expenditure(as % of GDP) of Myanmar in 1997 to that in 1999?
Offer a terse response. 1.01. What is the ratio of the Expenditure(as % of GDP) of Yemen, Rep. in 1997 to that in 1999?
Provide a succinct answer. 0.95. What is the ratio of the Expenditure(as % of GDP) of Botswana in 1997 to that in 2000?
Offer a terse response. 0.93. What is the ratio of the Expenditure(as % of GDP) of Burkina Faso in 1997 to that in 2000?
Keep it short and to the point. 0.88. What is the ratio of the Expenditure(as % of GDP) of Myanmar in 1997 to that in 2000?
Provide a succinct answer. 0.86. What is the ratio of the Expenditure(as % of GDP) in Yemen, Rep. in 1997 to that in 2000?
Provide a succinct answer. 0.98. What is the ratio of the Expenditure(as % of GDP) in Botswana in 1997 to that in 2001?
Your response must be concise. 0.85. What is the ratio of the Expenditure(as % of GDP) of Burkina Faso in 1997 to that in 2001?
Provide a short and direct response. 0.92. What is the ratio of the Expenditure(as % of GDP) of Myanmar in 1997 to that in 2001?
Offer a terse response. 0.88. What is the ratio of the Expenditure(as % of GDP) in Yemen, Rep. in 1997 to that in 2001?
Provide a short and direct response. 0.94. What is the ratio of the Expenditure(as % of GDP) of Botswana in 1998 to that in 1999?
Your answer should be very brief. 1.03. What is the ratio of the Expenditure(as % of GDP) in Burkina Faso in 1998 to that in 1999?
Provide a succinct answer. 0.89. What is the ratio of the Expenditure(as % of GDP) of Myanmar in 1998 to that in 1999?
Your response must be concise. 1.02. What is the ratio of the Expenditure(as % of GDP) of Yemen, Rep. in 1998 to that in 1999?
Keep it short and to the point. 1.16. What is the ratio of the Expenditure(as % of GDP) in Botswana in 1998 to that in 2000?
Offer a very short reply. 0.84. What is the ratio of the Expenditure(as % of GDP) of Burkina Faso in 1998 to that in 2000?
Provide a short and direct response. 0.91. What is the ratio of the Expenditure(as % of GDP) of Myanmar in 1998 to that in 2000?
Ensure brevity in your answer.  0.86. What is the ratio of the Expenditure(as % of GDP) of Yemen, Rep. in 1998 to that in 2000?
Offer a very short reply. 1.2. What is the ratio of the Expenditure(as % of GDP) in Botswana in 1998 to that in 2001?
Give a very brief answer. 0.77. What is the ratio of the Expenditure(as % of GDP) in Burkina Faso in 1998 to that in 2001?
Ensure brevity in your answer.  0.95. What is the ratio of the Expenditure(as % of GDP) in Myanmar in 1998 to that in 2001?
Ensure brevity in your answer.  0.88. What is the ratio of the Expenditure(as % of GDP) in Yemen, Rep. in 1998 to that in 2001?
Give a very brief answer. 1.15. What is the ratio of the Expenditure(as % of GDP) of Botswana in 1999 to that in 2000?
Give a very brief answer. 0.81. What is the ratio of the Expenditure(as % of GDP) of Burkina Faso in 1999 to that in 2000?
Your answer should be compact. 1.03. What is the ratio of the Expenditure(as % of GDP) of Myanmar in 1999 to that in 2000?
Ensure brevity in your answer.  0.85. What is the ratio of the Expenditure(as % of GDP) in Yemen, Rep. in 1999 to that in 2000?
Your answer should be very brief. 1.03. What is the ratio of the Expenditure(as % of GDP) in Botswana in 1999 to that in 2001?
Provide a succinct answer. 0.74. What is the ratio of the Expenditure(as % of GDP) in Burkina Faso in 1999 to that in 2001?
Provide a succinct answer. 1.07. What is the ratio of the Expenditure(as % of GDP) in Myanmar in 1999 to that in 2001?
Offer a very short reply. 0.86. What is the ratio of the Expenditure(as % of GDP) of Yemen, Rep. in 1999 to that in 2001?
Provide a short and direct response. 0.99. What is the ratio of the Expenditure(as % of GDP) in Botswana in 2000 to that in 2001?
Provide a succinct answer. 0.92. What is the ratio of the Expenditure(as % of GDP) in Burkina Faso in 2000 to that in 2001?
Your answer should be very brief. 1.04. What is the ratio of the Expenditure(as % of GDP) in Myanmar in 2000 to that in 2001?
Offer a terse response. 1.02. What is the ratio of the Expenditure(as % of GDP) in Yemen, Rep. in 2000 to that in 2001?
Provide a succinct answer. 0.95. What is the difference between the highest and the second highest Expenditure(as % of GDP) in Botswana?
Your answer should be very brief. 0.44. What is the difference between the highest and the second highest Expenditure(as % of GDP) of Burkina Faso?
Offer a terse response. 0.13. What is the difference between the highest and the second highest Expenditure(as % of GDP) in Myanmar?
Give a very brief answer. 0. What is the difference between the highest and the second highest Expenditure(as % of GDP) of Yemen, Rep.?
Your response must be concise. 0.64. What is the difference between the highest and the lowest Expenditure(as % of GDP) in Botswana?
Make the answer very short. 1.33. What is the difference between the highest and the lowest Expenditure(as % of GDP) of Burkina Faso?
Your response must be concise. 0.75. What is the difference between the highest and the lowest Expenditure(as % of GDP) of Myanmar?
Give a very brief answer. 0.32. What is the difference between the highest and the lowest Expenditure(as % of GDP) of Yemen, Rep.?
Ensure brevity in your answer.  0.91. 